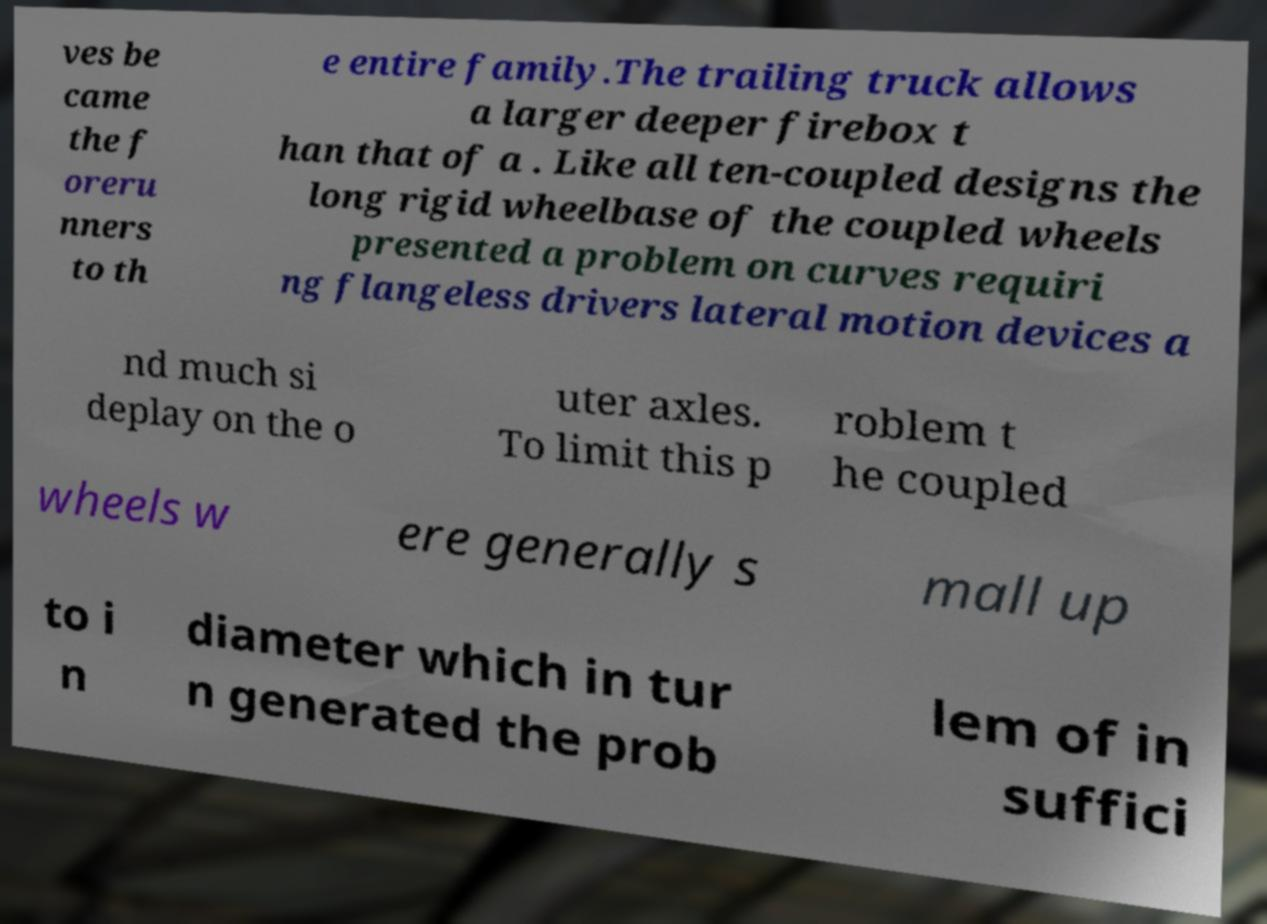Can you accurately transcribe the text from the provided image for me? ves be came the f oreru nners to th e entire family.The trailing truck allows a larger deeper firebox t han that of a . Like all ten-coupled designs the long rigid wheelbase of the coupled wheels presented a problem on curves requiri ng flangeless drivers lateral motion devices a nd much si deplay on the o uter axles. To limit this p roblem t he coupled wheels w ere generally s mall up to i n diameter which in tur n generated the prob lem of in suffici 